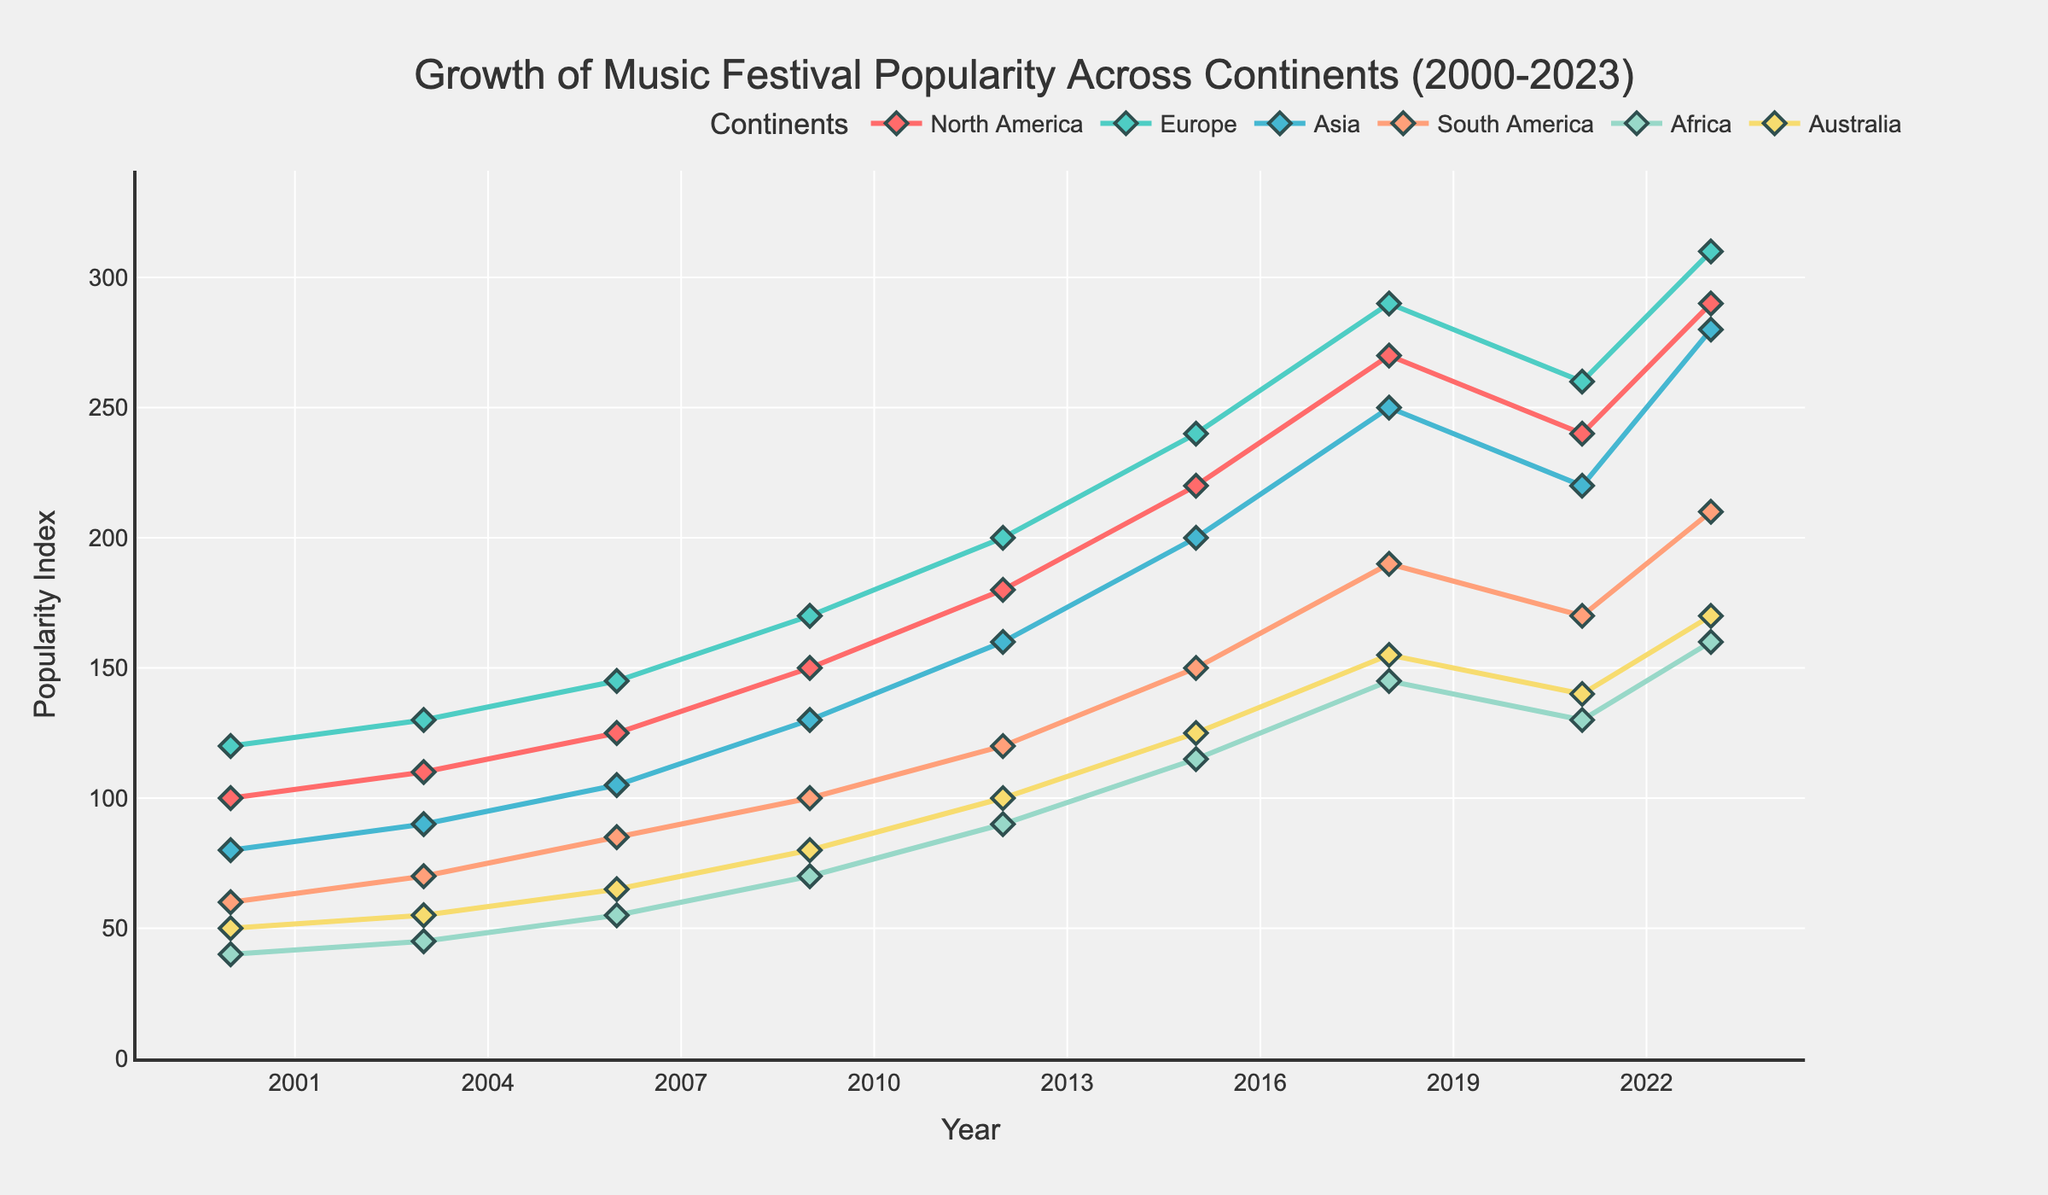Which continent showed the highest increase in festival popularity from 2000 to 2023? To find the highest increase, we subtract the popularity index of 2000 from that of 2023 for each continent. Calculate the values: North America (290-100=190), Europe (310-120=190), Asia (280-80=200), South America (210-60=150), Africa (160-40=120), Australia (170-50=120). The highest is Asia with an increase of 200.
Answer: Asia In what year did Europe surpass a popularity index of 200? Look for the point on the Europe line where it crosses the 200 mark which happens around the year 2012, as indicated by the rising trend in the figure.
Answer: 2012 Which continent had a decline in festival popularity between 2018 and 2021? By examining the trends between 2018 and 2021, one can see that North America (270 to 240), Europe (290 to 260), Asia (250 to 220), South America (190 to 170), Africa (145 to 130), and Australia (155 to 140) all show declines. Therefore, multiple continents experienced a decline during this period, but North America had a clear drop.
Answer: North America What is the difference in festival popularity between North America and Europe in 2023? Subtract the popularity index of North America from Europe in the year 2023: 310 - 290 = 20.
Answer: 20 How many continents had a popularity index greater than 100 in 2009? Check the 2009 data points: North America (150), Europe (170), Asia (130), South America (100), Africa (70), Australia (80). Count the ones greater than 100: North America, Europe, Asia, making it 3 continents.
Answer: 3 In which year did South America surpass Africa in festival popularity? Compare the data points for South America and Africa year by year. South America surpasses Africa between 2003 (70 vs. 45) as seen from their respective trends in the figure.
Answer: 2003 What is the average festival popularity for Australia between 2000 and 2023? Calculate the average by summing Australia's values: 50 + 55 + 65 + 80 + 100 + 125 + 155 + 140 + 170 = 940 and then dividing by the number of years: 940/9 = 104.4.
Answer: 104.4 Which continent had the closest growth trend to Asia? By visually comparing the slopes and data points' trends of each line, the closest growth trend to Asia is Europe as they follow a similar pattern of rise and fall over the years.
Answer: Europe What is the difference between the highest and the lowest popularity index among all continents in the year 2023? Identify the highest and lowest values in 2023: Highest is Europe (310) and lowest is Africa (160). The difference is 310 - 160 = 150.
Answer: 150 